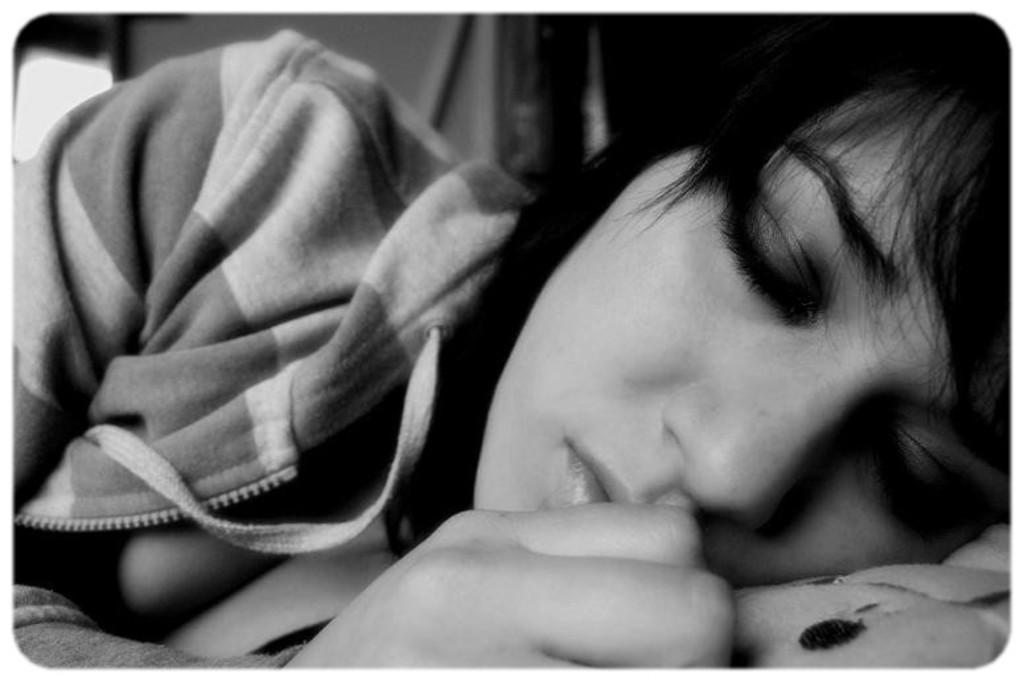Who is the main subject in the image? There is a woman in the image. What is the woman doing in the image? The woman is sleeping. Where is the woman located in the image? The woman is on a bed. How is the bed positioned in the image? The bed is in the center of the image. What type of gun is the woman holding in the image? There is no gun present in the image; the woman is sleeping on a bed. 